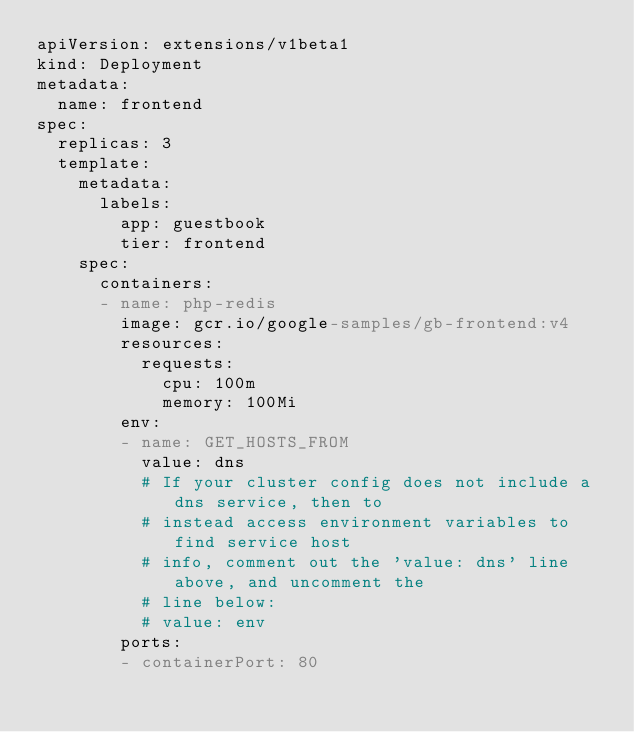Convert code to text. <code><loc_0><loc_0><loc_500><loc_500><_YAML_>apiVersion: extensions/v1beta1
kind: Deployment
metadata:
  name: frontend
spec:
  replicas: 3
  template:
    metadata:
      labels:
        app: guestbook
        tier: frontend
    spec:
      containers:
      - name: php-redis
        image: gcr.io/google-samples/gb-frontend:v4
        resources:
          requests:
            cpu: 100m
            memory: 100Mi
        env:
        - name: GET_HOSTS_FROM
          value: dns
          # If your cluster config does not include a dns service, then to
          # instead access environment variables to find service host
          # info, comment out the 'value: dns' line above, and uncomment the
          # line below:
          # value: env
        ports:
        - containerPort: 80

</code> 